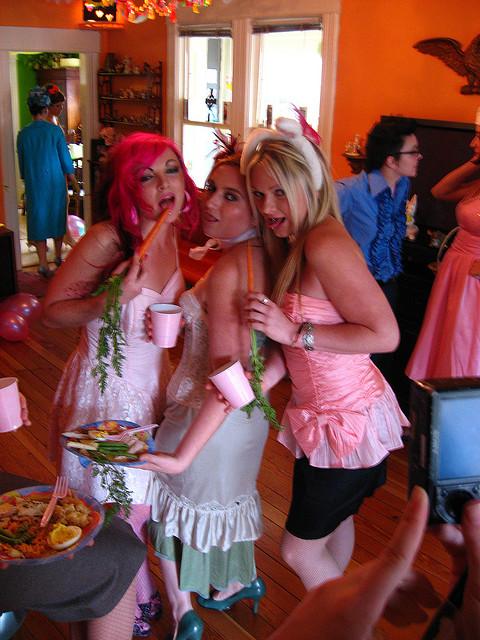Are the carrots skinny?
Concise answer only. Yes. How many girls are in the image?
Short answer required. 3. Are the young ladies sober?
Give a very brief answer. No. 